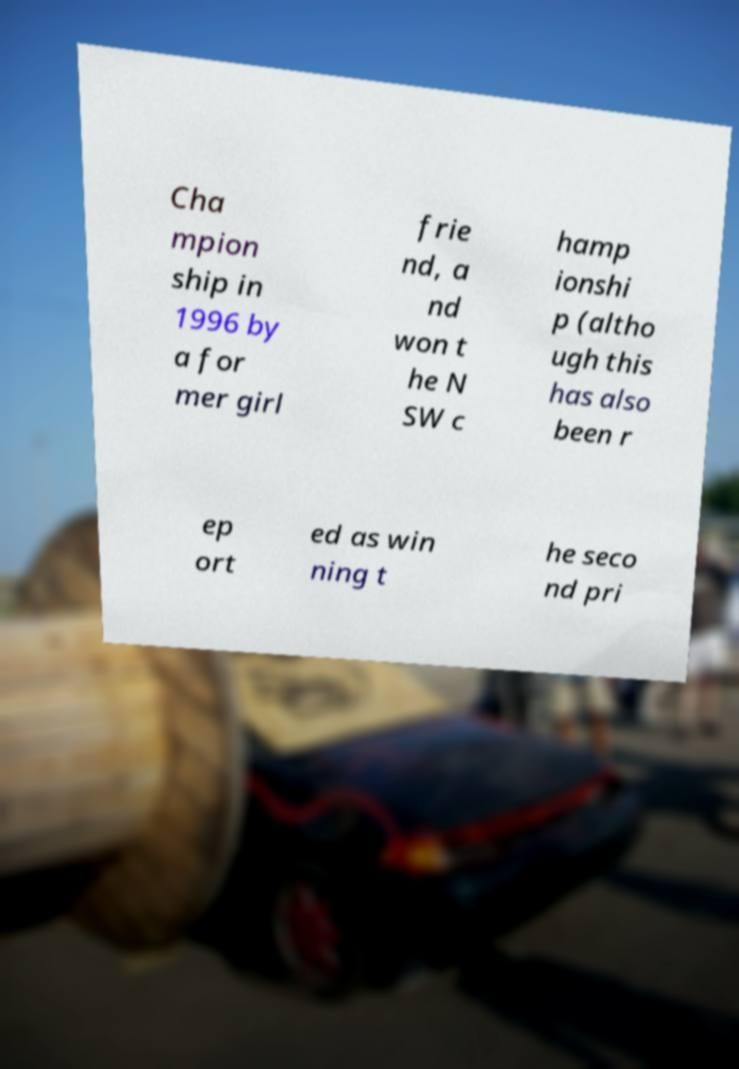What messages or text are displayed in this image? I need them in a readable, typed format. Cha mpion ship in 1996 by a for mer girl frie nd, a nd won t he N SW c hamp ionshi p (altho ugh this has also been r ep ort ed as win ning t he seco nd pri 